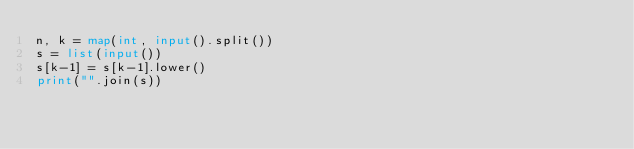<code> <loc_0><loc_0><loc_500><loc_500><_Python_>n, k = map(int, input().split())
s = list(input())
s[k-1] = s[k-1].lower()
print("".join(s))</code> 